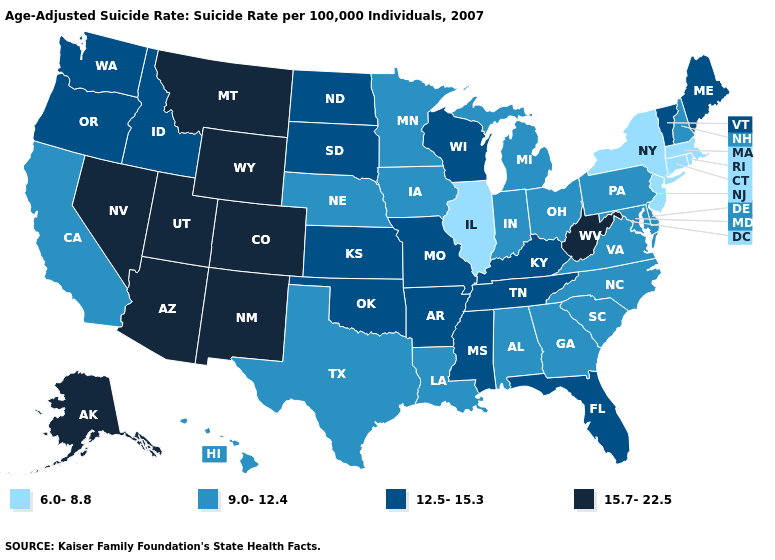Name the states that have a value in the range 15.7-22.5?
Answer briefly. Alaska, Arizona, Colorado, Montana, Nevada, New Mexico, Utah, West Virginia, Wyoming. What is the value of Kansas?
Answer briefly. 12.5-15.3. What is the value of Oregon?
Write a very short answer. 12.5-15.3. What is the value of Michigan?
Concise answer only. 9.0-12.4. What is the value of Idaho?
Give a very brief answer. 12.5-15.3. What is the value of Wisconsin?
Answer briefly. 12.5-15.3. Among the states that border Kentucky , does Illinois have the lowest value?
Give a very brief answer. Yes. What is the value of Maine?
Keep it brief. 12.5-15.3. What is the value of Tennessee?
Answer briefly. 12.5-15.3. Name the states that have a value in the range 15.7-22.5?
Answer briefly. Alaska, Arizona, Colorado, Montana, Nevada, New Mexico, Utah, West Virginia, Wyoming. What is the value of Oregon?
Concise answer only. 12.5-15.3. What is the highest value in the South ?
Write a very short answer. 15.7-22.5. Name the states that have a value in the range 15.7-22.5?
Quick response, please. Alaska, Arizona, Colorado, Montana, Nevada, New Mexico, Utah, West Virginia, Wyoming. What is the value of Utah?
Concise answer only. 15.7-22.5. 